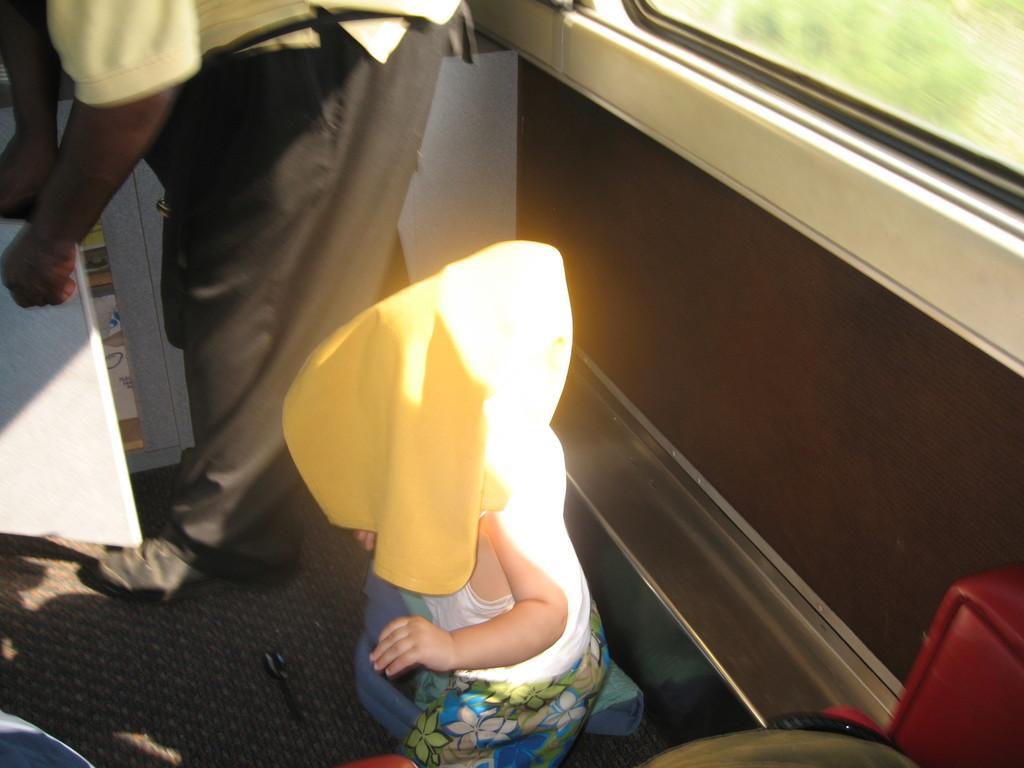Can you describe this image briefly? In this image I can see a kid standing and covering his face and head with a cloth. I can see another person beside the kid opening the door of a cupboard. This seems to be a train compartment.  